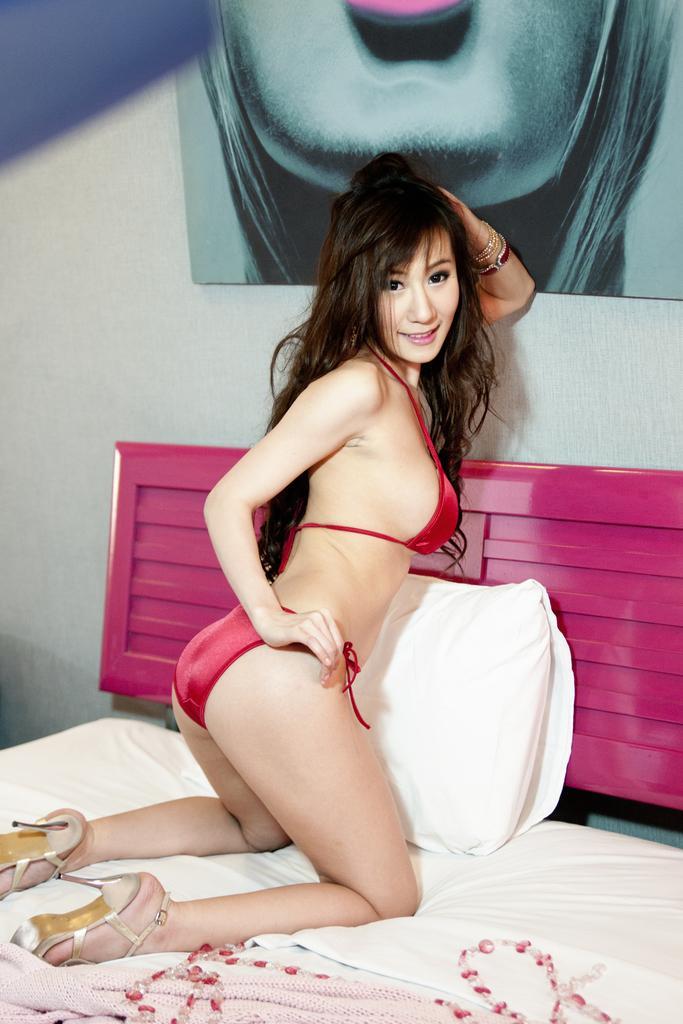How would you summarize this image in a sentence or two? This is the woman sitting on her knees on the bed and smiling. Here is the pillow. This bed is covered with a bed sheet. I can see a frame attached to the wall. 